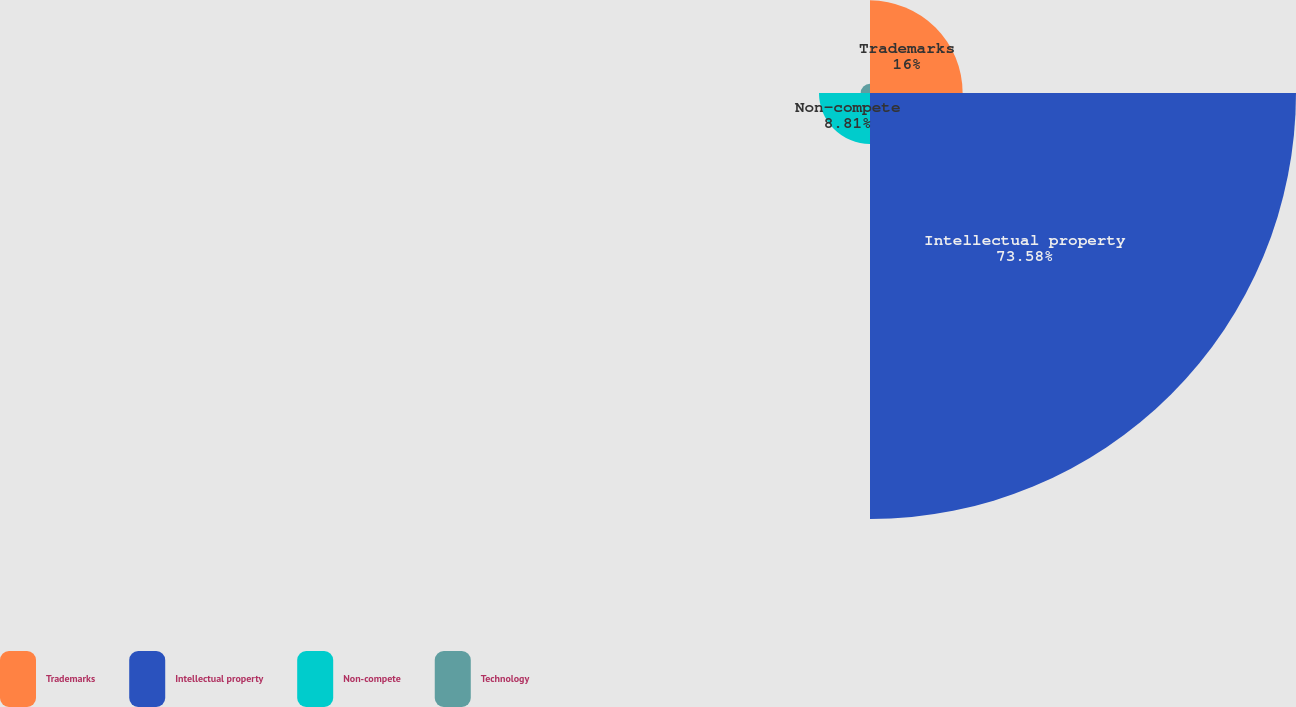Convert chart to OTSL. <chart><loc_0><loc_0><loc_500><loc_500><pie_chart><fcel>Trademarks<fcel>Intellectual property<fcel>Non-compete<fcel>Technology<nl><fcel>16.0%<fcel>73.58%<fcel>8.81%<fcel>1.61%<nl></chart> 